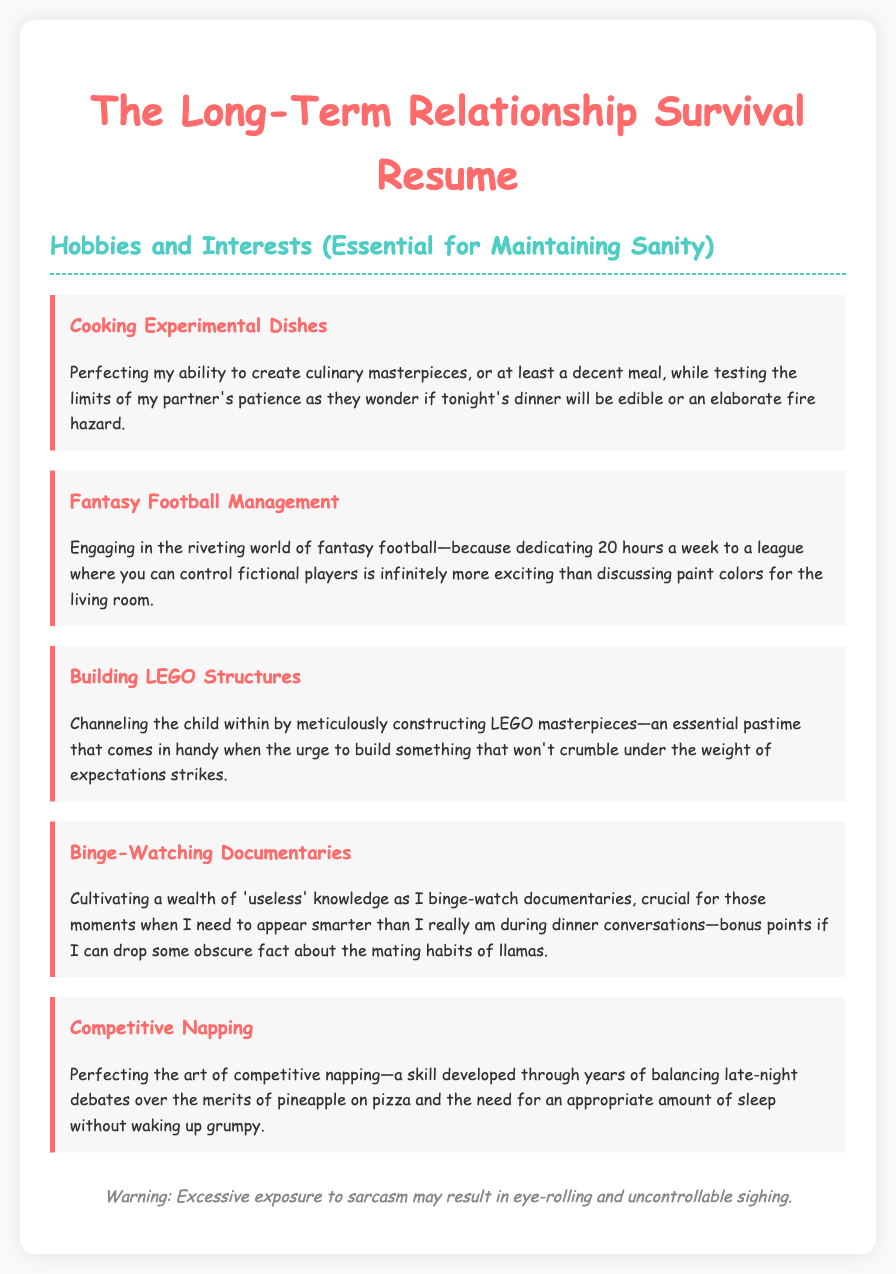What are the hobbies listed? The hobbies listed are the ones mentioned in the document under the "Hobbies and Interests" section, which include cooking, fantasy football, building LEGO, watching documentaries, and napping.
Answer: Cooking Experimental Dishes, Fantasy Football Management, Building LEGO Structures, Binge-Watching Documentaries, Competitive Napping Which hobby involves testing the partner's patience? The hobby that involves testing the partner’s patience is mentioned in the context of experimenting with food while cooking.
Answer: Cooking Experimental Dishes What skill is developed through late-night debates? The skill developed through late-night debates relates to the ability to nap competitively without becoming grumpy.
Answer: Competitive Napping Which hobby is said to make one appear smarter during conversations? The hobby that is crucial for appearing smarter during dinner conversations is binge-watching documentaries.
Answer: Binge-Watching Documentaries How many hours a week are dedicated to fantasy football management? The document explicitly states that 20 hours a week are dedicated to fantasy football management.
Answer: 20 hours 